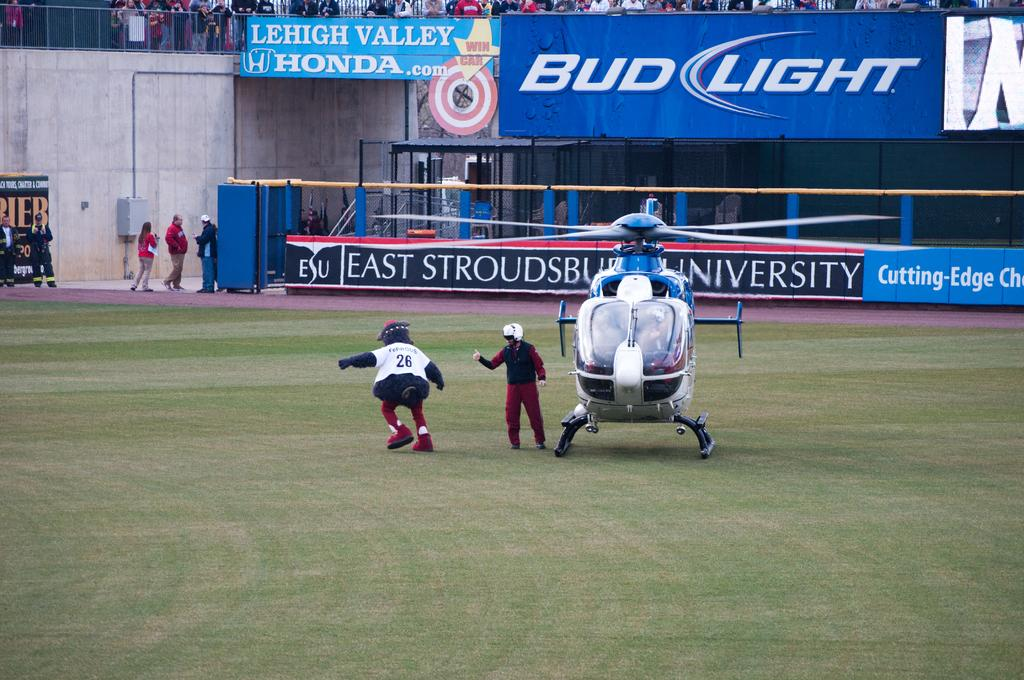<image>
Provide a brief description of the given image. Mascot wearing the jersey number 26 walking on the grass. 